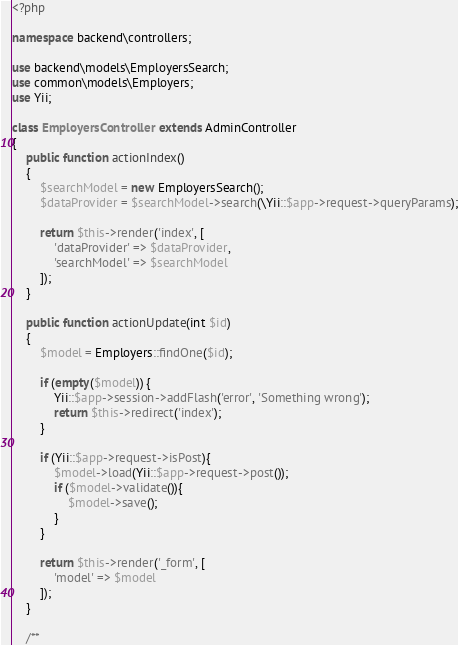<code> <loc_0><loc_0><loc_500><loc_500><_PHP_><?php

namespace backend\controllers;

use backend\models\EmployersSearch;
use common\models\Employers;
use Yii;

class EmployersController extends AdminController
{
    public function actionIndex()
    {
        $searchModel = new EmployersSearch();
        $dataProvider = $searchModel->search(\Yii::$app->request->queryParams);

        return $this->render('index', [
            'dataProvider' => $dataProvider,
            'searchModel' => $searchModel
        ]);
    }

    public function actionUpdate(int $id)
    {
        $model = Employers::findOne($id);

        if (empty($model)) {
            Yii::$app->session->addFlash('error', 'Something wrong');
            return $this->redirect('index');
        }

        if (Yii::$app->request->isPost){
            $model->load(Yii::$app->request->post());
            if ($model->validate()){
                $model->save();
            }
        }

        return $this->render('_form', [
            'model' => $model
        ]);
    }

    /**</code> 